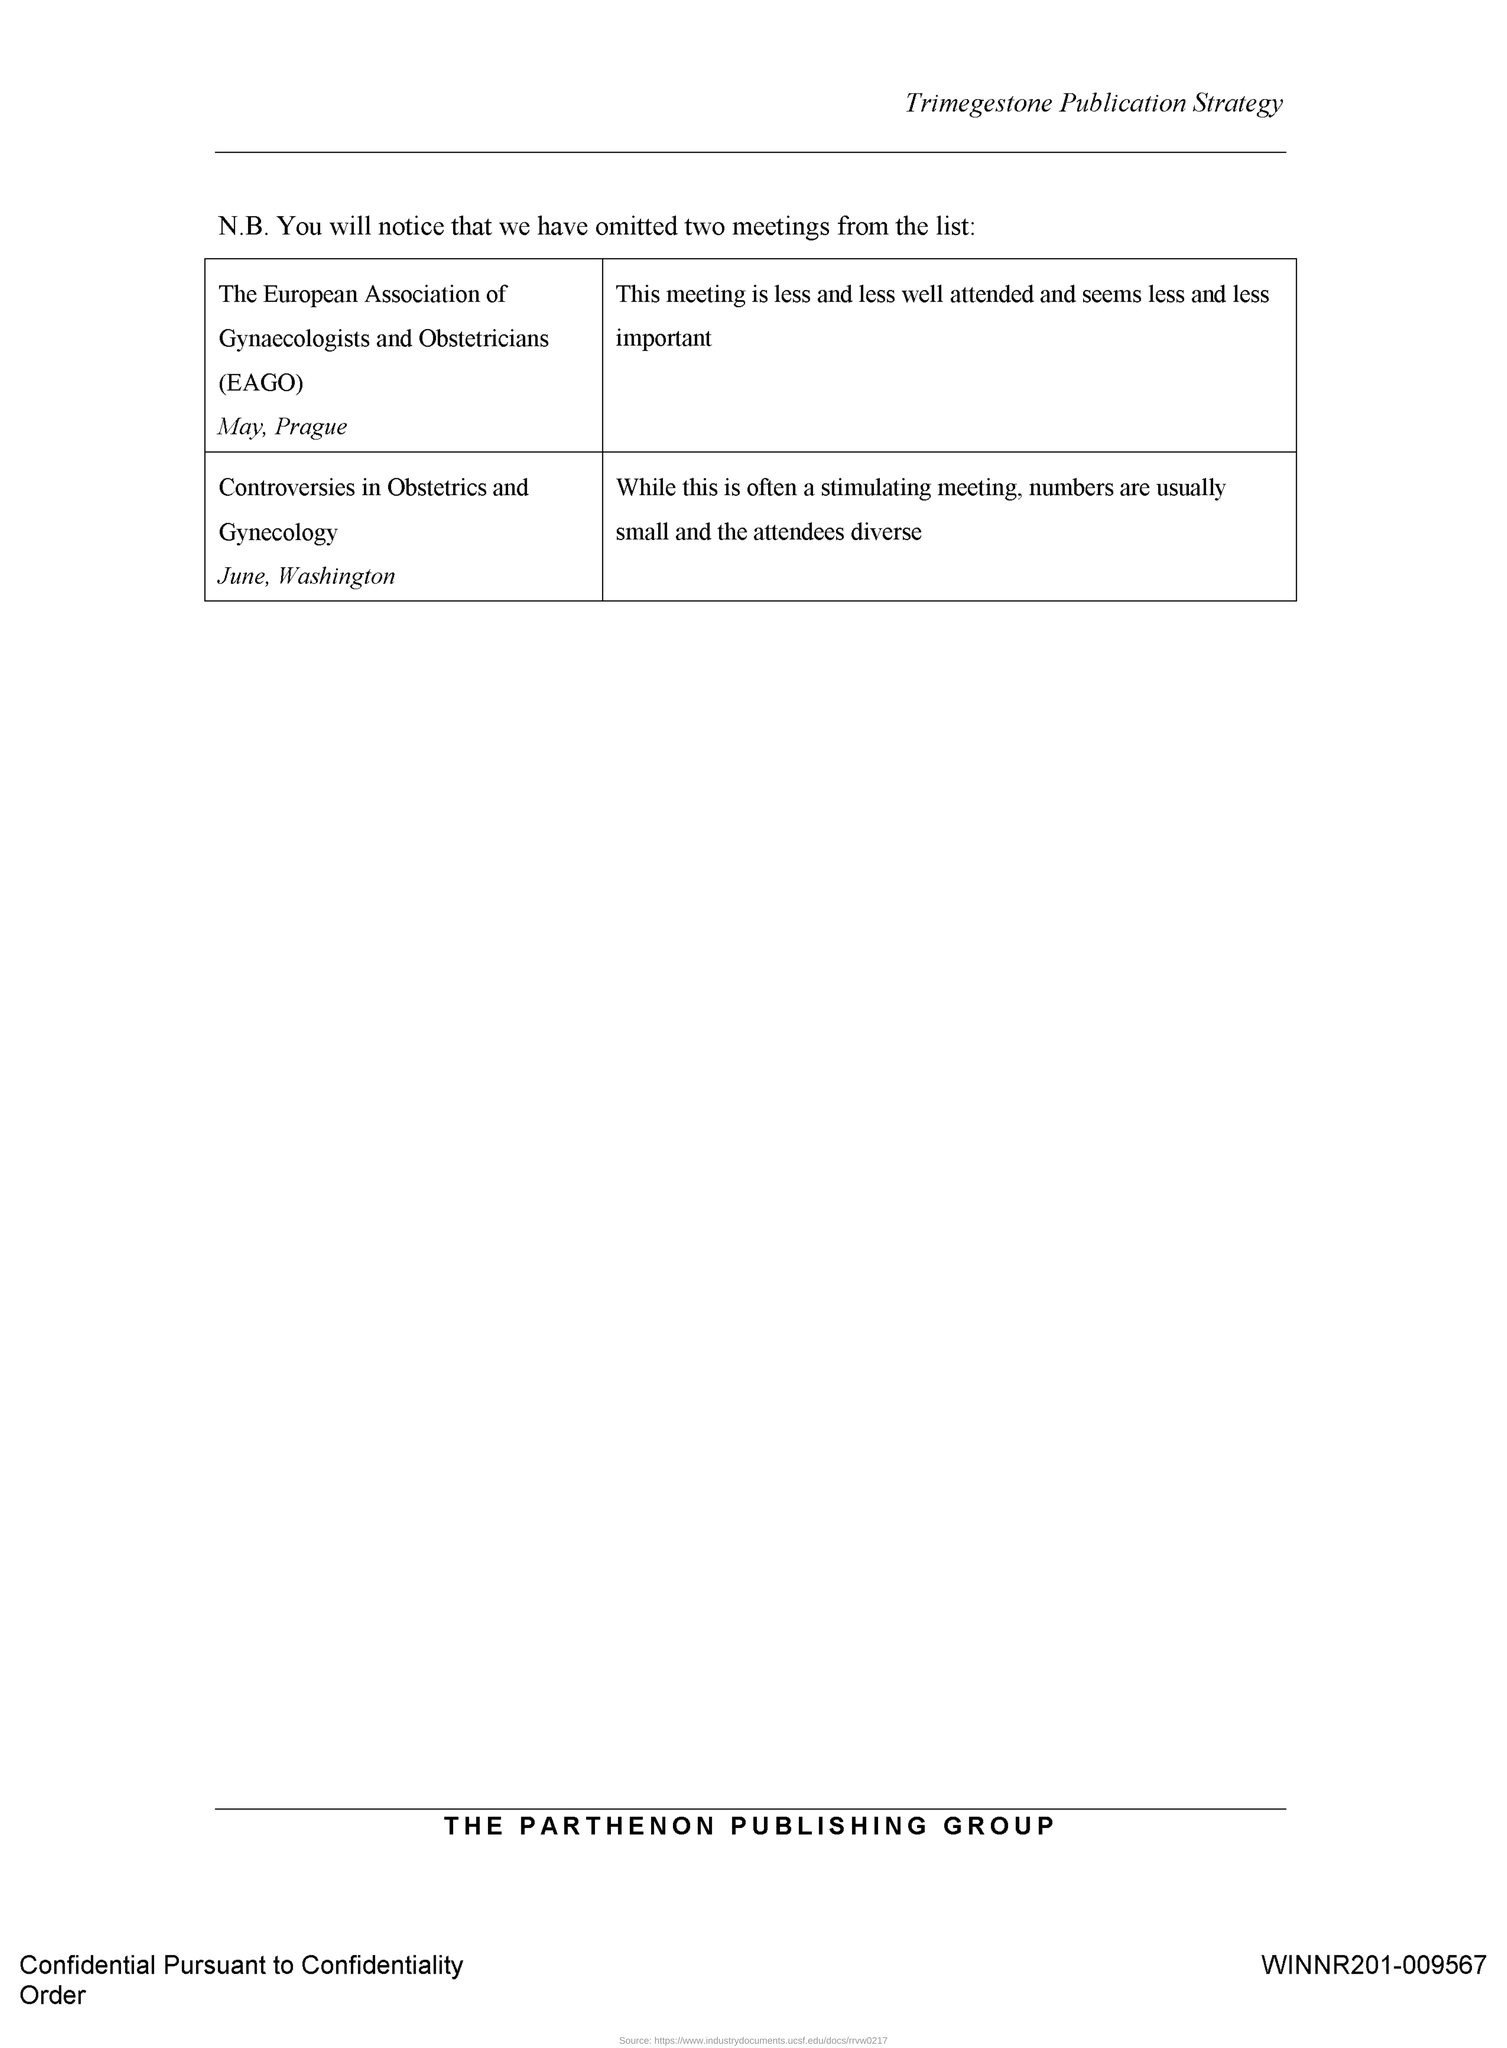What is the full form of EAGO?
Offer a terse response. EUROPEAN ASSOCIATION OF GYNAECOLOGISTS AND OBSTETRICIANS. The meeting EAGO is held in which place?
Your response must be concise. PRAGUE. The meeting EAGO is held in which month?
Provide a short and direct response. May. The meeting "Controversies in Obstetrics and Gynecology" is held in which place?
Offer a terse response. Washington. The meeting "Controversies in Obstetrics and Gynecology" is held in which month?
Provide a succinct answer. June. 